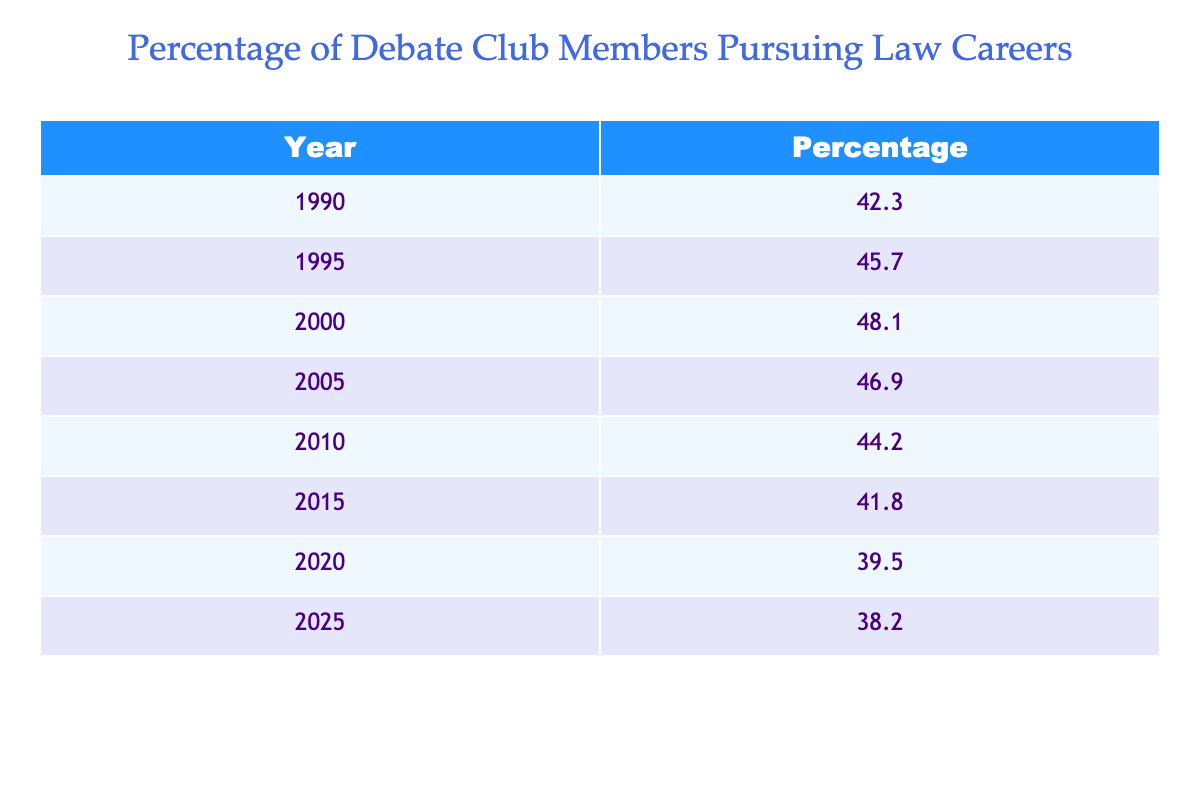What was the percentage of debate club members pursuing law careers in 2000? According to the table, the specific year 2000 shows a percentage value of 48.1%.
Answer: 48.1% In which year was the percentage of members pursuing law careers the highest? By looking at the table, the highest percentage is 48.1%, which occurs in the year 2000.
Answer: 2000 What is the average percentage of members pursuing law careers from 1990 to 2025? To find the average, we sum the percentages from 1990 (42.3), 1995 (45.7), 2000 (48.1), 2005 (46.9), 2010 (44.2), 2015 (41.8), 2020 (39.5), and 2025 (38.2). The total is 348.7, and dividing by 8 gives an average of 43.59.
Answer: 43.59 Did the percentage of members pursuing law careers increase from 1990 to 2010? The percentages for those years are 42.3% in 1990 and 44.2% in 2010. Since 44.2% is greater than 42.3%, it indicates an increase.
Answer: Yes What was the change in percentage from 2010 to 2025? The percentage in 2010 is 44.2% and in 2025, it is 38.2%. The change can be calculated as 38.2 - 44.2 = -6.0, indicating a decrease.
Answer: -6.0 Was the percentage lower in 2020 compared to 1995? The percentage for 2020 is 39.5%, while for 1995 it is 45.7%. Since 39.5% is less than 45.7%, the statement is true.
Answer: Yes What was the difference in percentage points between the highest and lowest values from 1990 to 2025? The highest percentage is 48.1% in 2000 and the lowest is 38.2% in 2025. The difference is calculated as 48.1 - 38.2 = 9.9 percentage points.
Answer: 9.9 In what years did the percentage decrease compared to the previous year? Looking at the table, the percentage decreased from 2005 to 2010 (46.9 to 44.2), from 2010 to 2015 (44.2 to 41.8), from 2015 to 2020 (41.8 to 39.5), and from 2020 to 2025 (39.5 to 38.2). Thus, the years are 2010, 2015, 2020, and 2025.
Answer: 2010, 2015, 2020, 2025 